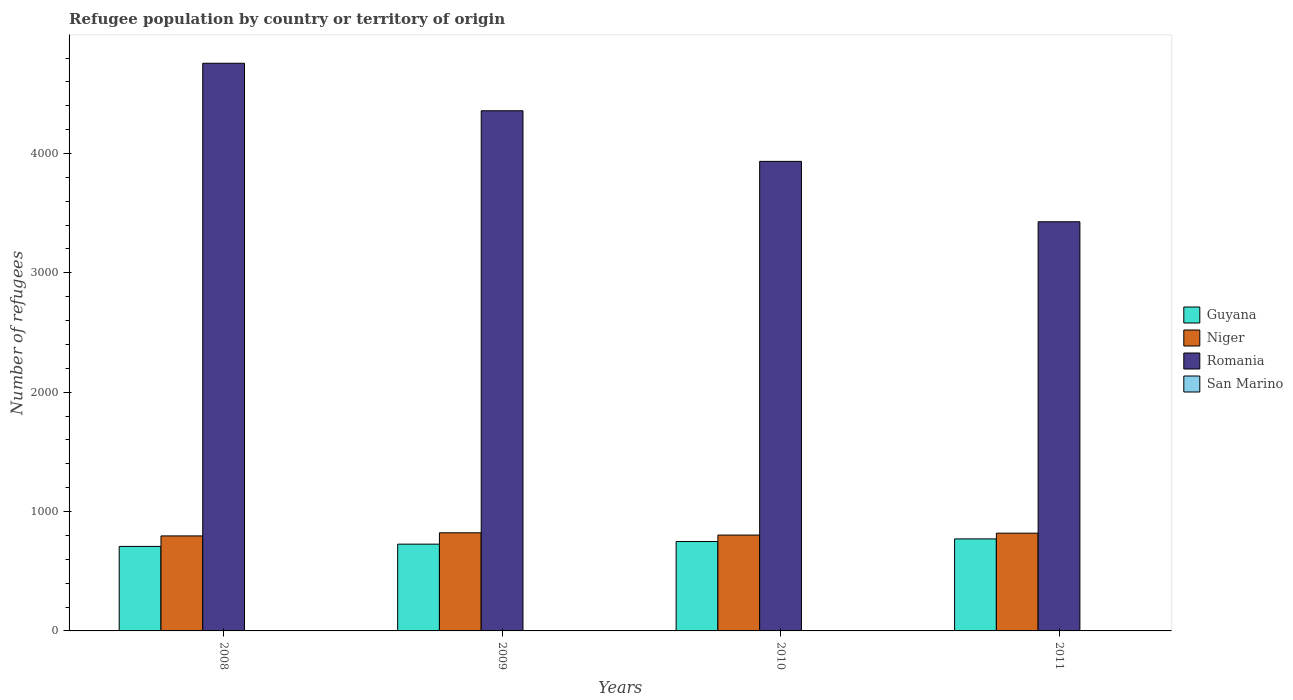Are the number of bars per tick equal to the number of legend labels?
Ensure brevity in your answer.  Yes. How many bars are there on the 1st tick from the right?
Keep it short and to the point. 4. What is the number of refugees in Niger in 2011?
Keep it short and to the point. 819. Across all years, what is the minimum number of refugees in Guyana?
Provide a succinct answer. 708. In which year was the number of refugees in San Marino maximum?
Make the answer very short. 2010. In which year was the number of refugees in Guyana minimum?
Your response must be concise. 2008. What is the total number of refugees in Guyana in the graph?
Make the answer very short. 2955. What is the difference between the number of refugees in Romania in 2008 and that in 2011?
Your response must be concise. 1328. What is the difference between the number of refugees in Romania in 2011 and the number of refugees in San Marino in 2010?
Your answer should be very brief. 3426. In the year 2011, what is the difference between the number of refugees in Romania and number of refugees in Guyana?
Make the answer very short. 2657. In how many years, is the number of refugees in Guyana greater than 2600?
Provide a succinct answer. 0. What is the ratio of the number of refugees in Niger in 2009 to that in 2010?
Your answer should be compact. 1.02. Is the number of refugees in Niger in 2009 less than that in 2010?
Keep it short and to the point. No. In how many years, is the number of refugees in San Marino greater than the average number of refugees in San Marino taken over all years?
Ensure brevity in your answer.  1. Is the sum of the number of refugees in Romania in 2008 and 2011 greater than the maximum number of refugees in Niger across all years?
Give a very brief answer. Yes. What does the 1st bar from the left in 2009 represents?
Provide a short and direct response. Guyana. What does the 1st bar from the right in 2010 represents?
Ensure brevity in your answer.  San Marino. How many bars are there?
Offer a very short reply. 16. Are all the bars in the graph horizontal?
Make the answer very short. No. How many years are there in the graph?
Your answer should be compact. 4. What is the difference between two consecutive major ticks on the Y-axis?
Make the answer very short. 1000. Does the graph contain grids?
Provide a succinct answer. No. How are the legend labels stacked?
Make the answer very short. Vertical. What is the title of the graph?
Ensure brevity in your answer.  Refugee population by country or territory of origin. Does "Sierra Leone" appear as one of the legend labels in the graph?
Provide a succinct answer. No. What is the label or title of the Y-axis?
Your answer should be very brief. Number of refugees. What is the Number of refugees in Guyana in 2008?
Your response must be concise. 708. What is the Number of refugees in Niger in 2008?
Your answer should be very brief. 796. What is the Number of refugees in Romania in 2008?
Provide a short and direct response. 4756. What is the Number of refugees of Guyana in 2009?
Your answer should be very brief. 727. What is the Number of refugees of Niger in 2009?
Ensure brevity in your answer.  822. What is the Number of refugees of Romania in 2009?
Keep it short and to the point. 4358. What is the Number of refugees in San Marino in 2009?
Ensure brevity in your answer.  1. What is the Number of refugees of Guyana in 2010?
Your answer should be very brief. 749. What is the Number of refugees of Niger in 2010?
Provide a succinct answer. 803. What is the Number of refugees of Romania in 2010?
Your answer should be compact. 3934. What is the Number of refugees of San Marino in 2010?
Provide a short and direct response. 2. What is the Number of refugees of Guyana in 2011?
Give a very brief answer. 771. What is the Number of refugees in Niger in 2011?
Your response must be concise. 819. What is the Number of refugees of Romania in 2011?
Give a very brief answer. 3428. Across all years, what is the maximum Number of refugees in Guyana?
Your response must be concise. 771. Across all years, what is the maximum Number of refugees in Niger?
Ensure brevity in your answer.  822. Across all years, what is the maximum Number of refugees in Romania?
Offer a terse response. 4756. Across all years, what is the minimum Number of refugees of Guyana?
Keep it short and to the point. 708. Across all years, what is the minimum Number of refugees of Niger?
Provide a short and direct response. 796. Across all years, what is the minimum Number of refugees of Romania?
Ensure brevity in your answer.  3428. What is the total Number of refugees in Guyana in the graph?
Make the answer very short. 2955. What is the total Number of refugees in Niger in the graph?
Offer a very short reply. 3240. What is the total Number of refugees in Romania in the graph?
Your answer should be compact. 1.65e+04. What is the total Number of refugees in San Marino in the graph?
Offer a terse response. 5. What is the difference between the Number of refugees of Niger in 2008 and that in 2009?
Keep it short and to the point. -26. What is the difference between the Number of refugees in Romania in 2008 and that in 2009?
Your answer should be very brief. 398. What is the difference between the Number of refugees of San Marino in 2008 and that in 2009?
Make the answer very short. 0. What is the difference between the Number of refugees in Guyana in 2008 and that in 2010?
Make the answer very short. -41. What is the difference between the Number of refugees in Niger in 2008 and that in 2010?
Make the answer very short. -7. What is the difference between the Number of refugees of Romania in 2008 and that in 2010?
Make the answer very short. 822. What is the difference between the Number of refugees in Guyana in 2008 and that in 2011?
Ensure brevity in your answer.  -63. What is the difference between the Number of refugees in Romania in 2008 and that in 2011?
Make the answer very short. 1328. What is the difference between the Number of refugees in San Marino in 2008 and that in 2011?
Make the answer very short. 0. What is the difference between the Number of refugees in Guyana in 2009 and that in 2010?
Your answer should be compact. -22. What is the difference between the Number of refugees of Romania in 2009 and that in 2010?
Give a very brief answer. 424. What is the difference between the Number of refugees in Guyana in 2009 and that in 2011?
Ensure brevity in your answer.  -44. What is the difference between the Number of refugees of Niger in 2009 and that in 2011?
Keep it short and to the point. 3. What is the difference between the Number of refugees of Romania in 2009 and that in 2011?
Your answer should be very brief. 930. What is the difference between the Number of refugees of San Marino in 2009 and that in 2011?
Your answer should be compact. 0. What is the difference between the Number of refugees in Niger in 2010 and that in 2011?
Offer a terse response. -16. What is the difference between the Number of refugees of Romania in 2010 and that in 2011?
Provide a succinct answer. 506. What is the difference between the Number of refugees of San Marino in 2010 and that in 2011?
Give a very brief answer. 1. What is the difference between the Number of refugees of Guyana in 2008 and the Number of refugees of Niger in 2009?
Provide a succinct answer. -114. What is the difference between the Number of refugees of Guyana in 2008 and the Number of refugees of Romania in 2009?
Your response must be concise. -3650. What is the difference between the Number of refugees of Guyana in 2008 and the Number of refugees of San Marino in 2009?
Provide a succinct answer. 707. What is the difference between the Number of refugees in Niger in 2008 and the Number of refugees in Romania in 2009?
Make the answer very short. -3562. What is the difference between the Number of refugees of Niger in 2008 and the Number of refugees of San Marino in 2009?
Your answer should be very brief. 795. What is the difference between the Number of refugees in Romania in 2008 and the Number of refugees in San Marino in 2009?
Your response must be concise. 4755. What is the difference between the Number of refugees of Guyana in 2008 and the Number of refugees of Niger in 2010?
Keep it short and to the point. -95. What is the difference between the Number of refugees in Guyana in 2008 and the Number of refugees in Romania in 2010?
Your answer should be compact. -3226. What is the difference between the Number of refugees in Guyana in 2008 and the Number of refugees in San Marino in 2010?
Give a very brief answer. 706. What is the difference between the Number of refugees of Niger in 2008 and the Number of refugees of Romania in 2010?
Your answer should be very brief. -3138. What is the difference between the Number of refugees in Niger in 2008 and the Number of refugees in San Marino in 2010?
Your answer should be compact. 794. What is the difference between the Number of refugees in Romania in 2008 and the Number of refugees in San Marino in 2010?
Your response must be concise. 4754. What is the difference between the Number of refugees of Guyana in 2008 and the Number of refugees of Niger in 2011?
Offer a very short reply. -111. What is the difference between the Number of refugees in Guyana in 2008 and the Number of refugees in Romania in 2011?
Offer a very short reply. -2720. What is the difference between the Number of refugees in Guyana in 2008 and the Number of refugees in San Marino in 2011?
Provide a short and direct response. 707. What is the difference between the Number of refugees in Niger in 2008 and the Number of refugees in Romania in 2011?
Your answer should be compact. -2632. What is the difference between the Number of refugees in Niger in 2008 and the Number of refugees in San Marino in 2011?
Offer a very short reply. 795. What is the difference between the Number of refugees of Romania in 2008 and the Number of refugees of San Marino in 2011?
Offer a terse response. 4755. What is the difference between the Number of refugees in Guyana in 2009 and the Number of refugees in Niger in 2010?
Your answer should be compact. -76. What is the difference between the Number of refugees in Guyana in 2009 and the Number of refugees in Romania in 2010?
Offer a terse response. -3207. What is the difference between the Number of refugees of Guyana in 2009 and the Number of refugees of San Marino in 2010?
Keep it short and to the point. 725. What is the difference between the Number of refugees of Niger in 2009 and the Number of refugees of Romania in 2010?
Make the answer very short. -3112. What is the difference between the Number of refugees in Niger in 2009 and the Number of refugees in San Marino in 2010?
Keep it short and to the point. 820. What is the difference between the Number of refugees of Romania in 2009 and the Number of refugees of San Marino in 2010?
Give a very brief answer. 4356. What is the difference between the Number of refugees in Guyana in 2009 and the Number of refugees in Niger in 2011?
Keep it short and to the point. -92. What is the difference between the Number of refugees in Guyana in 2009 and the Number of refugees in Romania in 2011?
Provide a short and direct response. -2701. What is the difference between the Number of refugees in Guyana in 2009 and the Number of refugees in San Marino in 2011?
Your answer should be very brief. 726. What is the difference between the Number of refugees of Niger in 2009 and the Number of refugees of Romania in 2011?
Your answer should be compact. -2606. What is the difference between the Number of refugees of Niger in 2009 and the Number of refugees of San Marino in 2011?
Your answer should be compact. 821. What is the difference between the Number of refugees in Romania in 2009 and the Number of refugees in San Marino in 2011?
Make the answer very short. 4357. What is the difference between the Number of refugees of Guyana in 2010 and the Number of refugees of Niger in 2011?
Make the answer very short. -70. What is the difference between the Number of refugees of Guyana in 2010 and the Number of refugees of Romania in 2011?
Make the answer very short. -2679. What is the difference between the Number of refugees in Guyana in 2010 and the Number of refugees in San Marino in 2011?
Your answer should be very brief. 748. What is the difference between the Number of refugees of Niger in 2010 and the Number of refugees of Romania in 2011?
Give a very brief answer. -2625. What is the difference between the Number of refugees of Niger in 2010 and the Number of refugees of San Marino in 2011?
Your answer should be compact. 802. What is the difference between the Number of refugees of Romania in 2010 and the Number of refugees of San Marino in 2011?
Keep it short and to the point. 3933. What is the average Number of refugees in Guyana per year?
Your response must be concise. 738.75. What is the average Number of refugees of Niger per year?
Your answer should be very brief. 810. What is the average Number of refugees in Romania per year?
Offer a terse response. 4119. What is the average Number of refugees in San Marino per year?
Your answer should be very brief. 1.25. In the year 2008, what is the difference between the Number of refugees of Guyana and Number of refugees of Niger?
Provide a short and direct response. -88. In the year 2008, what is the difference between the Number of refugees in Guyana and Number of refugees in Romania?
Your answer should be very brief. -4048. In the year 2008, what is the difference between the Number of refugees of Guyana and Number of refugees of San Marino?
Make the answer very short. 707. In the year 2008, what is the difference between the Number of refugees in Niger and Number of refugees in Romania?
Keep it short and to the point. -3960. In the year 2008, what is the difference between the Number of refugees of Niger and Number of refugees of San Marino?
Give a very brief answer. 795. In the year 2008, what is the difference between the Number of refugees in Romania and Number of refugees in San Marino?
Make the answer very short. 4755. In the year 2009, what is the difference between the Number of refugees in Guyana and Number of refugees in Niger?
Provide a short and direct response. -95. In the year 2009, what is the difference between the Number of refugees in Guyana and Number of refugees in Romania?
Your answer should be compact. -3631. In the year 2009, what is the difference between the Number of refugees in Guyana and Number of refugees in San Marino?
Provide a short and direct response. 726. In the year 2009, what is the difference between the Number of refugees of Niger and Number of refugees of Romania?
Your response must be concise. -3536. In the year 2009, what is the difference between the Number of refugees of Niger and Number of refugees of San Marino?
Make the answer very short. 821. In the year 2009, what is the difference between the Number of refugees in Romania and Number of refugees in San Marino?
Your answer should be compact. 4357. In the year 2010, what is the difference between the Number of refugees of Guyana and Number of refugees of Niger?
Give a very brief answer. -54. In the year 2010, what is the difference between the Number of refugees of Guyana and Number of refugees of Romania?
Offer a very short reply. -3185. In the year 2010, what is the difference between the Number of refugees of Guyana and Number of refugees of San Marino?
Offer a terse response. 747. In the year 2010, what is the difference between the Number of refugees of Niger and Number of refugees of Romania?
Offer a very short reply. -3131. In the year 2010, what is the difference between the Number of refugees of Niger and Number of refugees of San Marino?
Ensure brevity in your answer.  801. In the year 2010, what is the difference between the Number of refugees in Romania and Number of refugees in San Marino?
Provide a short and direct response. 3932. In the year 2011, what is the difference between the Number of refugees of Guyana and Number of refugees of Niger?
Make the answer very short. -48. In the year 2011, what is the difference between the Number of refugees in Guyana and Number of refugees in Romania?
Provide a short and direct response. -2657. In the year 2011, what is the difference between the Number of refugees of Guyana and Number of refugees of San Marino?
Offer a very short reply. 770. In the year 2011, what is the difference between the Number of refugees in Niger and Number of refugees in Romania?
Offer a very short reply. -2609. In the year 2011, what is the difference between the Number of refugees of Niger and Number of refugees of San Marino?
Your answer should be compact. 818. In the year 2011, what is the difference between the Number of refugees of Romania and Number of refugees of San Marino?
Your answer should be compact. 3427. What is the ratio of the Number of refugees in Guyana in 2008 to that in 2009?
Offer a very short reply. 0.97. What is the ratio of the Number of refugees of Niger in 2008 to that in 2009?
Make the answer very short. 0.97. What is the ratio of the Number of refugees of Romania in 2008 to that in 2009?
Ensure brevity in your answer.  1.09. What is the ratio of the Number of refugees of San Marino in 2008 to that in 2009?
Give a very brief answer. 1. What is the ratio of the Number of refugees of Guyana in 2008 to that in 2010?
Make the answer very short. 0.95. What is the ratio of the Number of refugees in Romania in 2008 to that in 2010?
Provide a succinct answer. 1.21. What is the ratio of the Number of refugees in San Marino in 2008 to that in 2010?
Your response must be concise. 0.5. What is the ratio of the Number of refugees of Guyana in 2008 to that in 2011?
Give a very brief answer. 0.92. What is the ratio of the Number of refugees of Niger in 2008 to that in 2011?
Make the answer very short. 0.97. What is the ratio of the Number of refugees in Romania in 2008 to that in 2011?
Provide a short and direct response. 1.39. What is the ratio of the Number of refugees of Guyana in 2009 to that in 2010?
Provide a short and direct response. 0.97. What is the ratio of the Number of refugees in Niger in 2009 to that in 2010?
Offer a very short reply. 1.02. What is the ratio of the Number of refugees of Romania in 2009 to that in 2010?
Provide a short and direct response. 1.11. What is the ratio of the Number of refugees of Guyana in 2009 to that in 2011?
Ensure brevity in your answer.  0.94. What is the ratio of the Number of refugees of Niger in 2009 to that in 2011?
Provide a succinct answer. 1. What is the ratio of the Number of refugees of Romania in 2009 to that in 2011?
Offer a very short reply. 1.27. What is the ratio of the Number of refugees of San Marino in 2009 to that in 2011?
Keep it short and to the point. 1. What is the ratio of the Number of refugees in Guyana in 2010 to that in 2011?
Your answer should be compact. 0.97. What is the ratio of the Number of refugees of Niger in 2010 to that in 2011?
Your response must be concise. 0.98. What is the ratio of the Number of refugees of Romania in 2010 to that in 2011?
Provide a short and direct response. 1.15. What is the ratio of the Number of refugees of San Marino in 2010 to that in 2011?
Your answer should be compact. 2. What is the difference between the highest and the second highest Number of refugees in Guyana?
Give a very brief answer. 22. What is the difference between the highest and the second highest Number of refugees of Niger?
Give a very brief answer. 3. What is the difference between the highest and the second highest Number of refugees of Romania?
Your response must be concise. 398. What is the difference between the highest and the second highest Number of refugees of San Marino?
Your answer should be compact. 1. What is the difference between the highest and the lowest Number of refugees in Guyana?
Offer a very short reply. 63. What is the difference between the highest and the lowest Number of refugees in Romania?
Ensure brevity in your answer.  1328. What is the difference between the highest and the lowest Number of refugees in San Marino?
Offer a terse response. 1. 